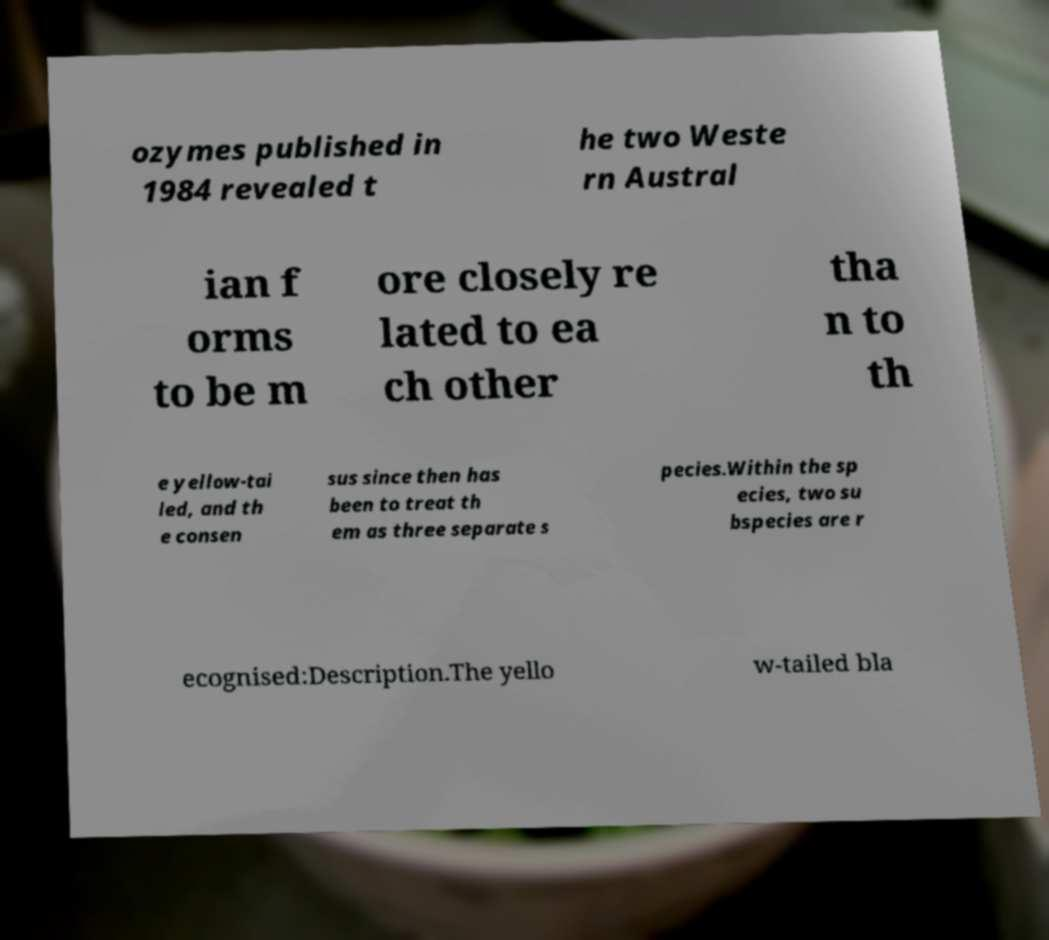There's text embedded in this image that I need extracted. Can you transcribe it verbatim? ozymes published in 1984 revealed t he two Weste rn Austral ian f orms to be m ore closely re lated to ea ch other tha n to th e yellow-tai led, and th e consen sus since then has been to treat th em as three separate s pecies.Within the sp ecies, two su bspecies are r ecognised:Description.The yello w-tailed bla 